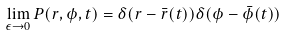Convert formula to latex. <formula><loc_0><loc_0><loc_500><loc_500>\lim _ { \epsilon \rightarrow 0 } P ( r , \phi , t ) = \delta ( r - \bar { r } ( t ) ) \delta ( \phi - \bar { \phi } ( t ) )</formula> 